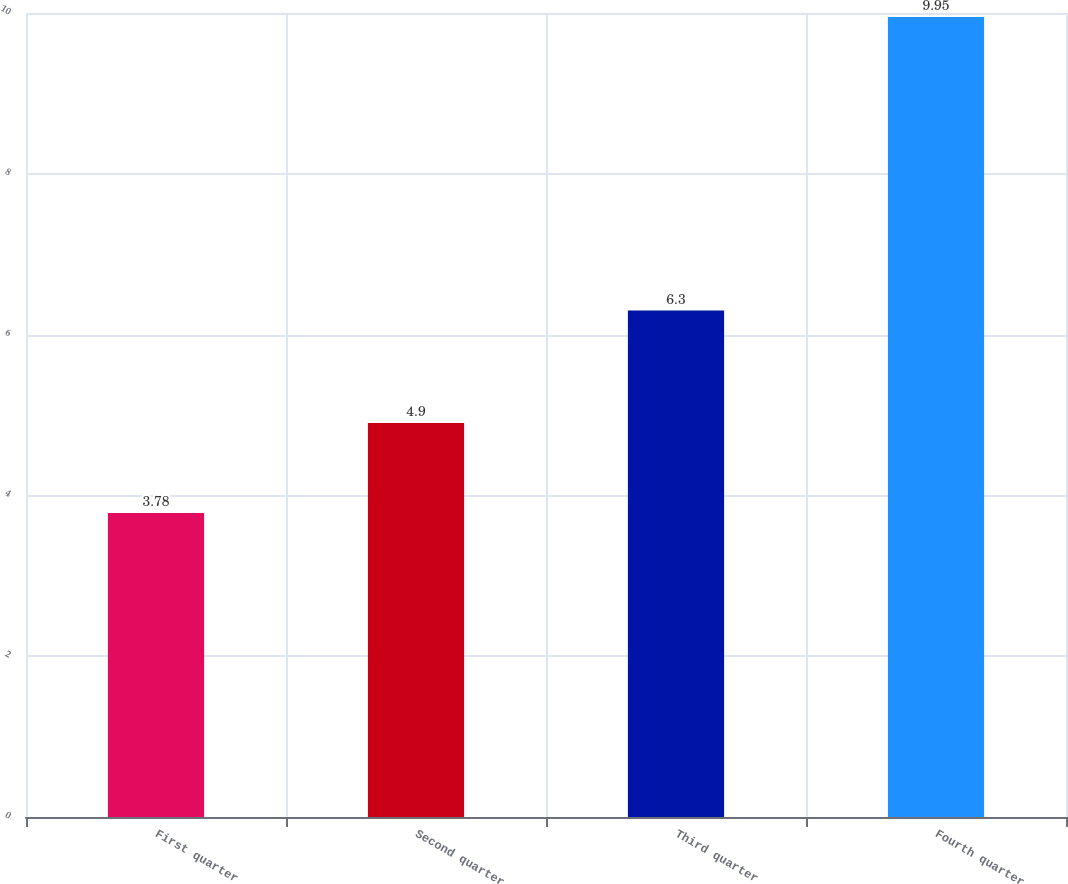<chart> <loc_0><loc_0><loc_500><loc_500><bar_chart><fcel>First quarter<fcel>Second quarter<fcel>Third quarter<fcel>Fourth quarter<nl><fcel>3.78<fcel>4.9<fcel>6.3<fcel>9.95<nl></chart> 